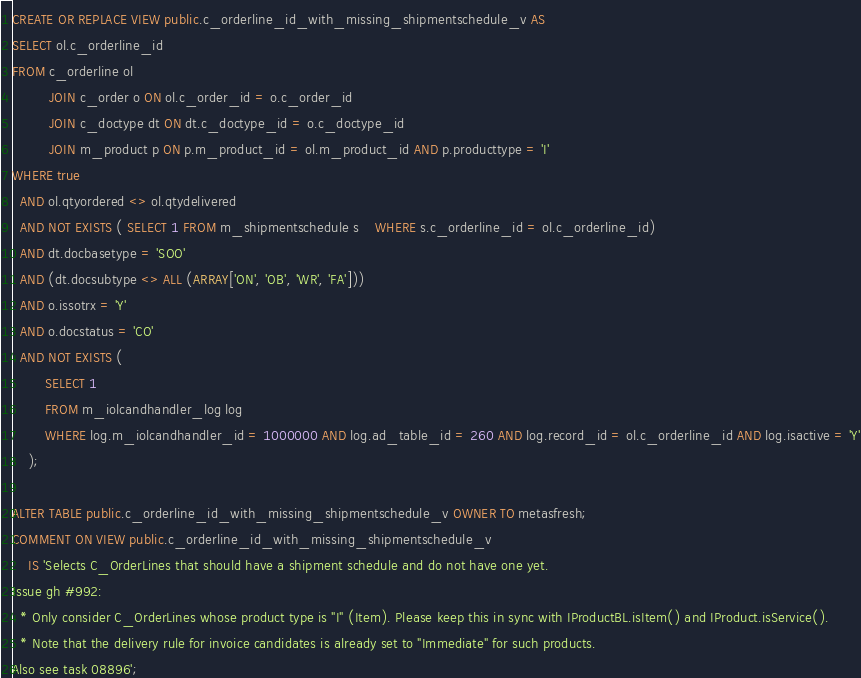Convert code to text. <code><loc_0><loc_0><loc_500><loc_500><_SQL_>CREATE OR REPLACE VIEW public.c_orderline_id_with_missing_shipmentschedule_v AS
SELECT ol.c_orderline_id
FROM c_orderline ol
         JOIN c_order o ON ol.c_order_id = o.c_order_id
         JOIN c_doctype dt ON dt.c_doctype_id = o.c_doctype_id
         JOIN m_product p ON p.m_product_id = ol.m_product_id AND p.producttype = 'I'
WHERE true
  AND ol.qtyordered <> ol.qtydelivered
  AND NOT EXISTS ( SELECT 1 FROM m_shipmentschedule s	WHERE s.c_orderline_id = ol.c_orderline_id)
  AND dt.docbasetype = 'SOO'
  AND (dt.docsubtype <> ALL (ARRAY['ON', 'OB', 'WR', 'FA']))
  AND o.issotrx = 'Y'
  AND o.docstatus = 'CO'
  AND NOT EXISTS (
        SELECT 1
        FROM m_iolcandhandler_log log
        WHERE log.m_iolcandhandler_id = 1000000 AND log.ad_table_id = 260 AND log.record_id = ol.c_orderline_id AND log.isactive = 'Y'
    );

ALTER TABLE public.c_orderline_id_with_missing_shipmentschedule_v OWNER TO metasfresh;
COMMENT ON VIEW public.c_orderline_id_with_missing_shipmentschedule_v
    IS 'Selects C_OrderLines that should have a shipment schedule and do not have one yet.
Issue gh #992:
  * Only consider C_OrderLines whose product type is "I" (Item). Please keep this in sync with IProductBL.isItem() and IProduct.isService().
  * Note that the delivery rule for invoice candidates is already set to "Immediate" for such products.
Also see task 08896';</code> 